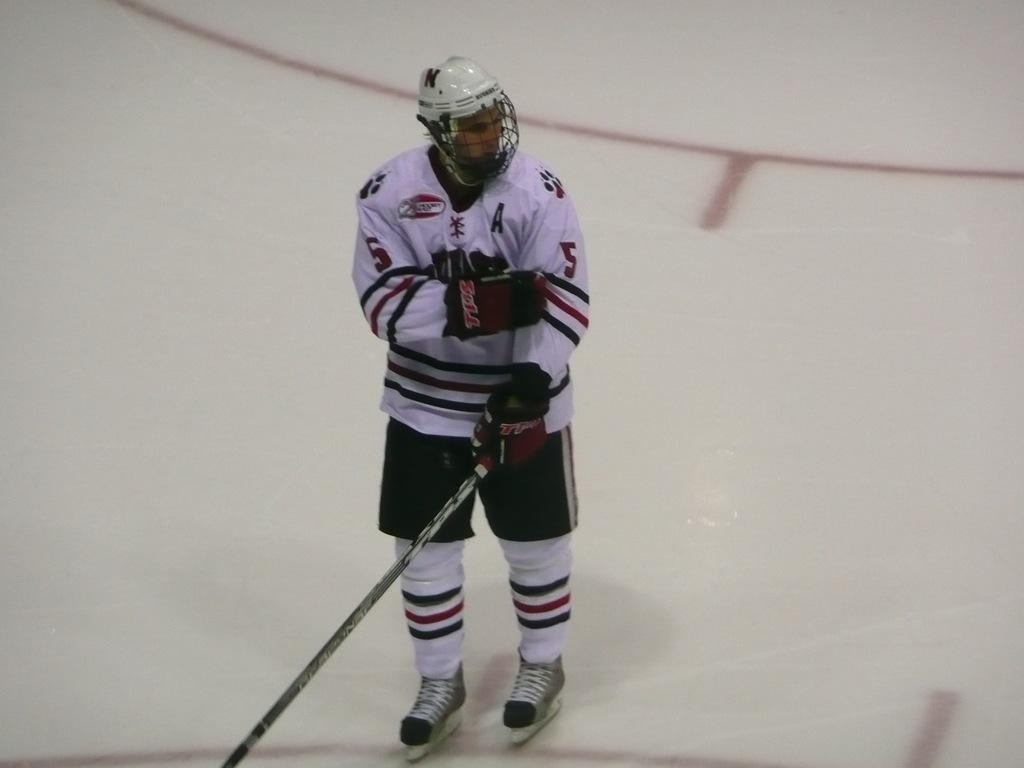What is the main subject of the image? There is a person in the image. What is the person doing in the image? The person is standing on the ground. What object is the person holding in the image? The person is holding a stick. What type of beds can be seen in the image? There are no beds present in the image; it features a person standing on the ground and holding a stick. What hobbies does the person have, as depicted in the image? The image does not provide information about the person's hobbies; it only shows them standing on the ground and holding a stick. 